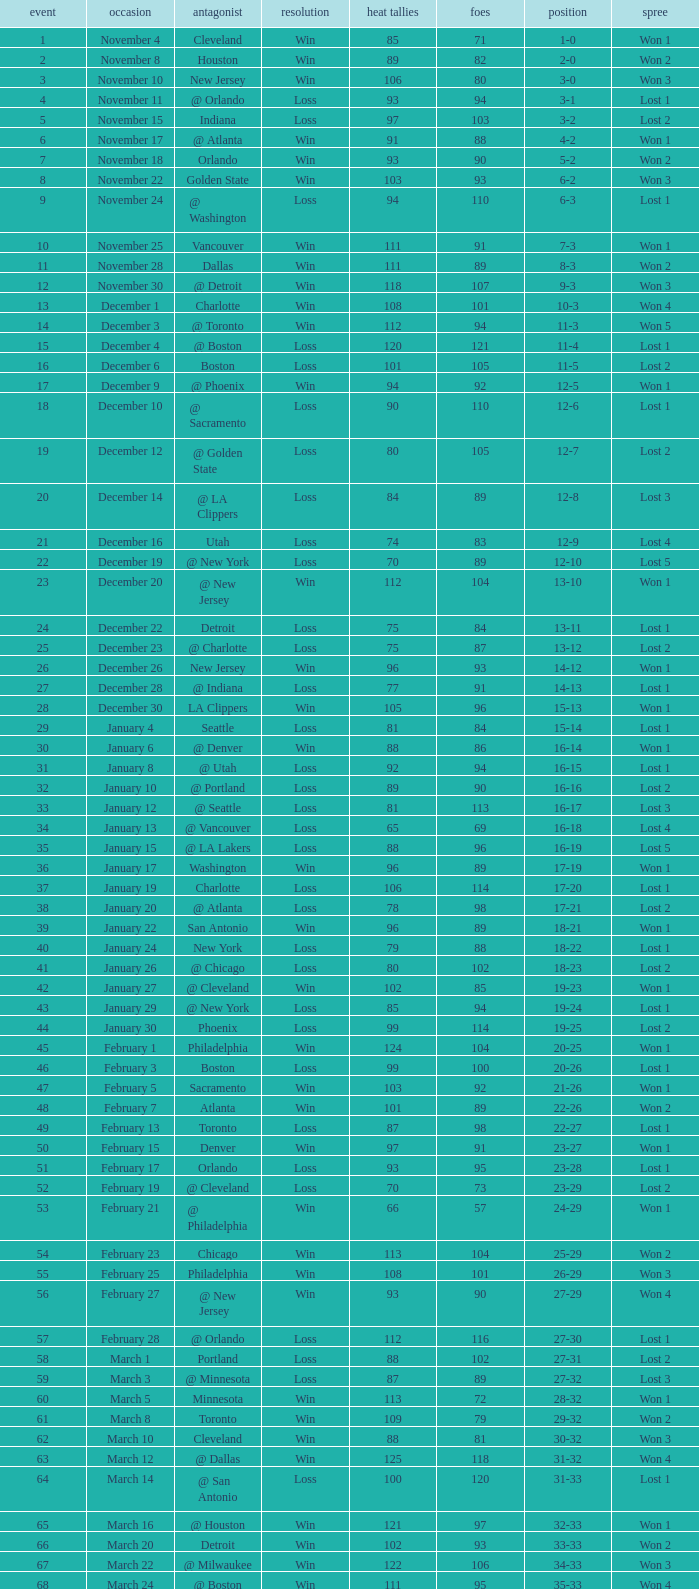What is the average Heat Points, when Result is "Loss", when Game is greater than 72, and when Date is "April 21"? 92.0. 